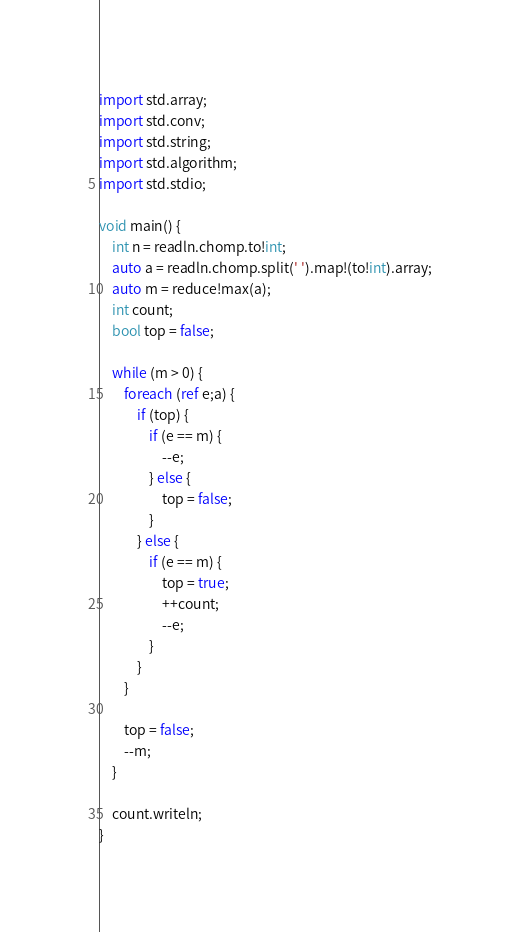Convert code to text. <code><loc_0><loc_0><loc_500><loc_500><_D_>import std.array;
import std.conv;
import std.string;
import std.algorithm;
import std.stdio;

void main() {
	int n = readln.chomp.to!int;
	auto a = readln.chomp.split(' ').map!(to!int).array;
	auto m = reduce!max(a);
	int count;
	bool top = false;

	while (m > 0) {
		foreach (ref e;a) {
			if (top) {
				if (e == m) {
					--e;
				} else {
					top = false;
				}
			} else {
				if (e == m) {
					top = true;
					++count;
					--e;
				}
			}
		}

		top = false;
		--m;
	}

	count.writeln;
}
</code> 